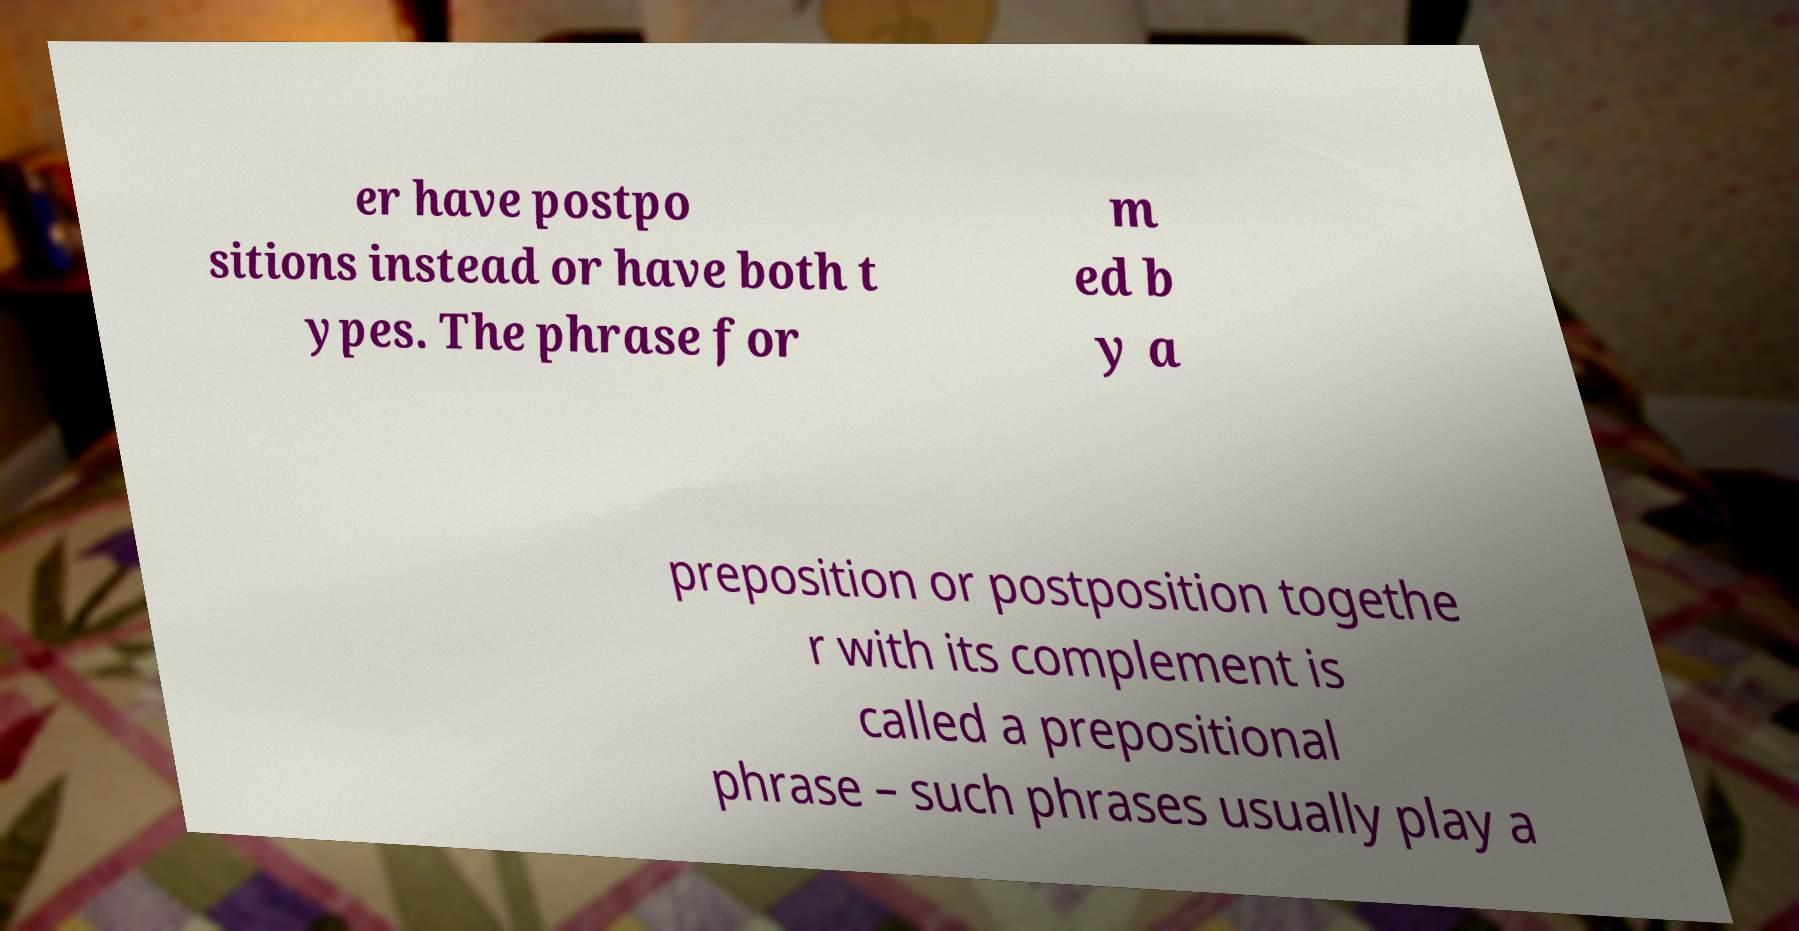I need the written content from this picture converted into text. Can you do that? er have postpo sitions instead or have both t ypes. The phrase for m ed b y a preposition or postposition togethe r with its complement is called a prepositional phrase – such phrases usually play a 